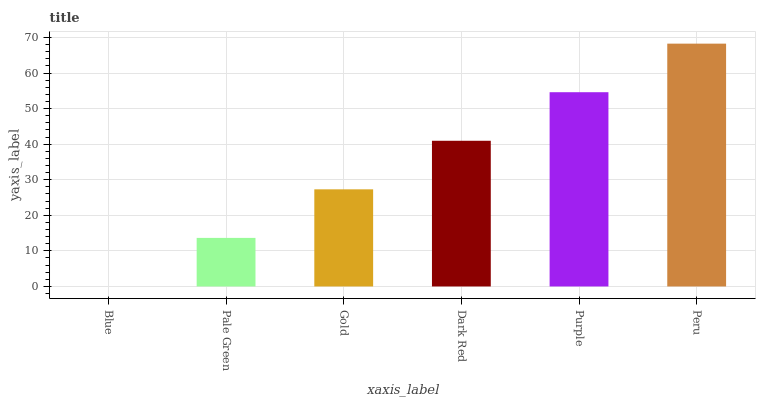Is Blue the minimum?
Answer yes or no. Yes. Is Peru the maximum?
Answer yes or no. Yes. Is Pale Green the minimum?
Answer yes or no. No. Is Pale Green the maximum?
Answer yes or no. No. Is Pale Green greater than Blue?
Answer yes or no. Yes. Is Blue less than Pale Green?
Answer yes or no. Yes. Is Blue greater than Pale Green?
Answer yes or no. No. Is Pale Green less than Blue?
Answer yes or no. No. Is Dark Red the high median?
Answer yes or no. Yes. Is Gold the low median?
Answer yes or no. Yes. Is Peru the high median?
Answer yes or no. No. Is Pale Green the low median?
Answer yes or no. No. 